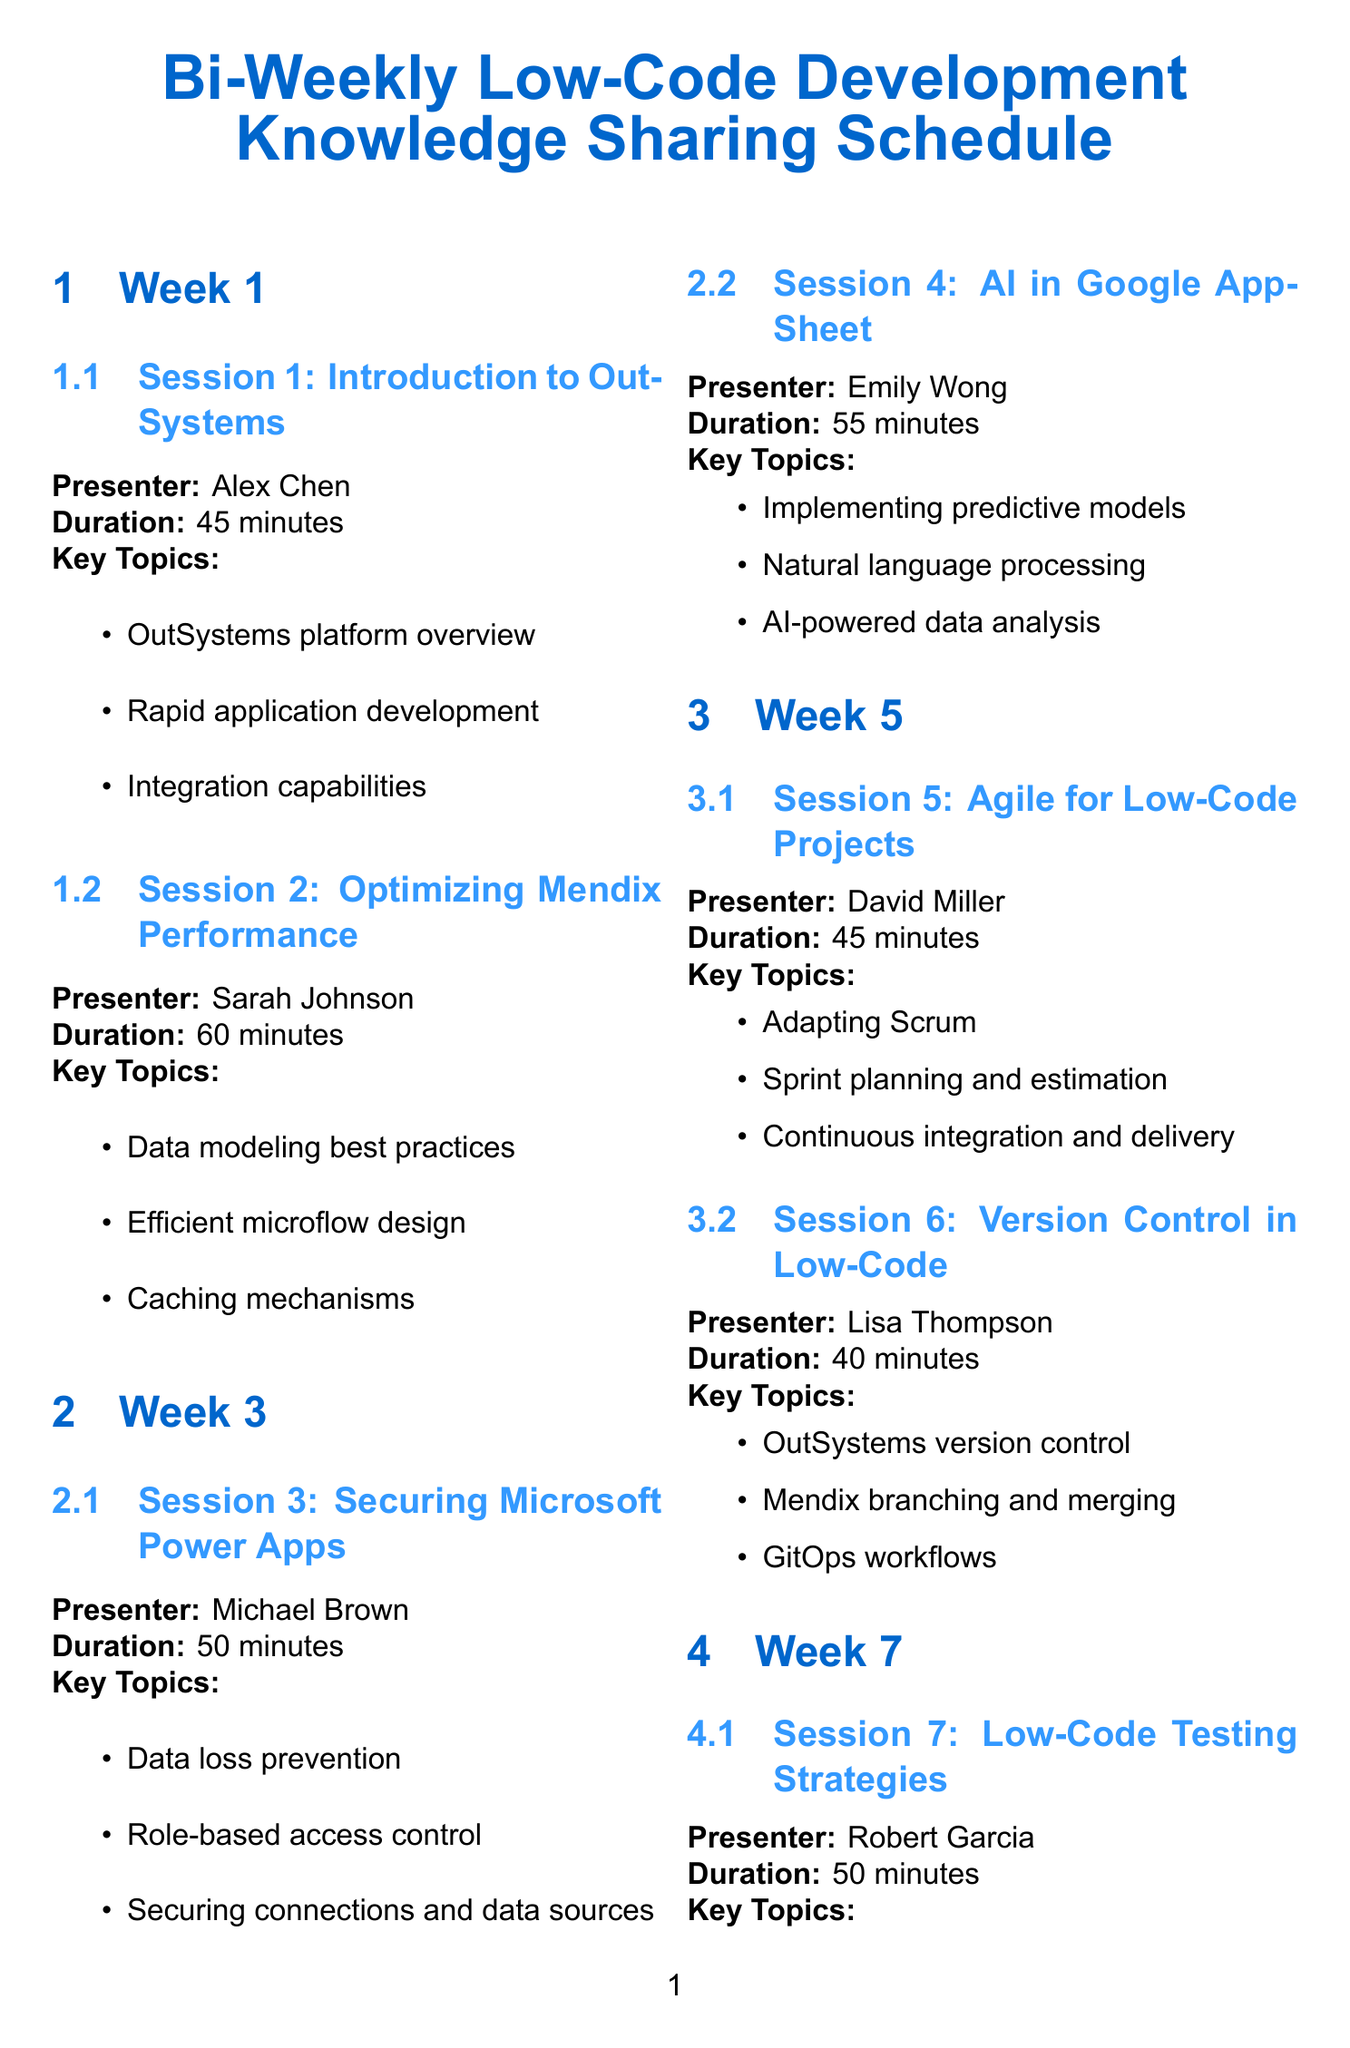What is the title of the first session? The title of the first session is retrieved from the document under "Week 1" section, it is "Introduction to OutSystems: A Leading Low-Code Platform".
Answer: Introduction to OutSystems: A Leading Low-Code Platform Who is the presenter for the session on securing low-code applications? The presenter's name is found in the "Securing Low-Code Applications: Microsoft Power Apps Focus" session details. The presenter's name is Michael Brown.
Answer: Michael Brown How long is the session on optimizing performance in Mendix applications? The duration of the session is stated in the session details under "Optimizing Performance in Mendix Applications". It is 60 minutes.
Answer: 60 minutes What is a key topic discussed in the session about version control? The key topics are listed under "Mastering Version Control in Low-Code Platforms"; one of them is "Version control best practices for OutSystems".
Answer: Version control best practices for OutSystems Which platform is focused on in the session led by Sarah Johnson? The platform mentioned is identified in the title of the session; it is Mendix, as indicated in "Optimizing Performance in Mendix Applications".
Answer: Mendix What is one of the key topics of the session on scaling low-code applications? The key topics are listed in the "Scaling Low-Code Applications: From Prototype to Enterprise"; one topic is "Architectural considerations for large-scale low-code apps".
Answer: Architectural considerations for large-scale low-code apps How many sessions are scheduled in week 5? The document lists the sessions under "Week 5", which includes two sessions, one about Agile and another about version control.
Answer: 2 sessions Who is the presenter for the session on leveraging AI in low-code development? The presenter’s name is provided in the session details under "Leveraging AI in Low-Code Development with Google AppSheet", which is Emily Wong.
Answer: Emily Wong 